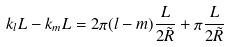<formula> <loc_0><loc_0><loc_500><loc_500>k _ { l } L - k _ { m } L = 2 \pi ( l - m ) \frac { L } { 2 \tilde { R } } + \pi \frac { L } { 2 \tilde { R } }</formula> 